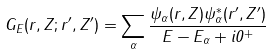Convert formula to latex. <formula><loc_0><loc_0><loc_500><loc_500>G _ { E } ( r , Z ; r ^ { \prime } , Z ^ { \prime } ) = \sum _ { \alpha } \frac { \psi _ { \alpha } ( r , Z ) \psi ^ { * } _ { \alpha } ( r ^ { \prime } , Z ^ { \prime } ) } { E - E _ { \alpha } + i 0 ^ { + } }</formula> 